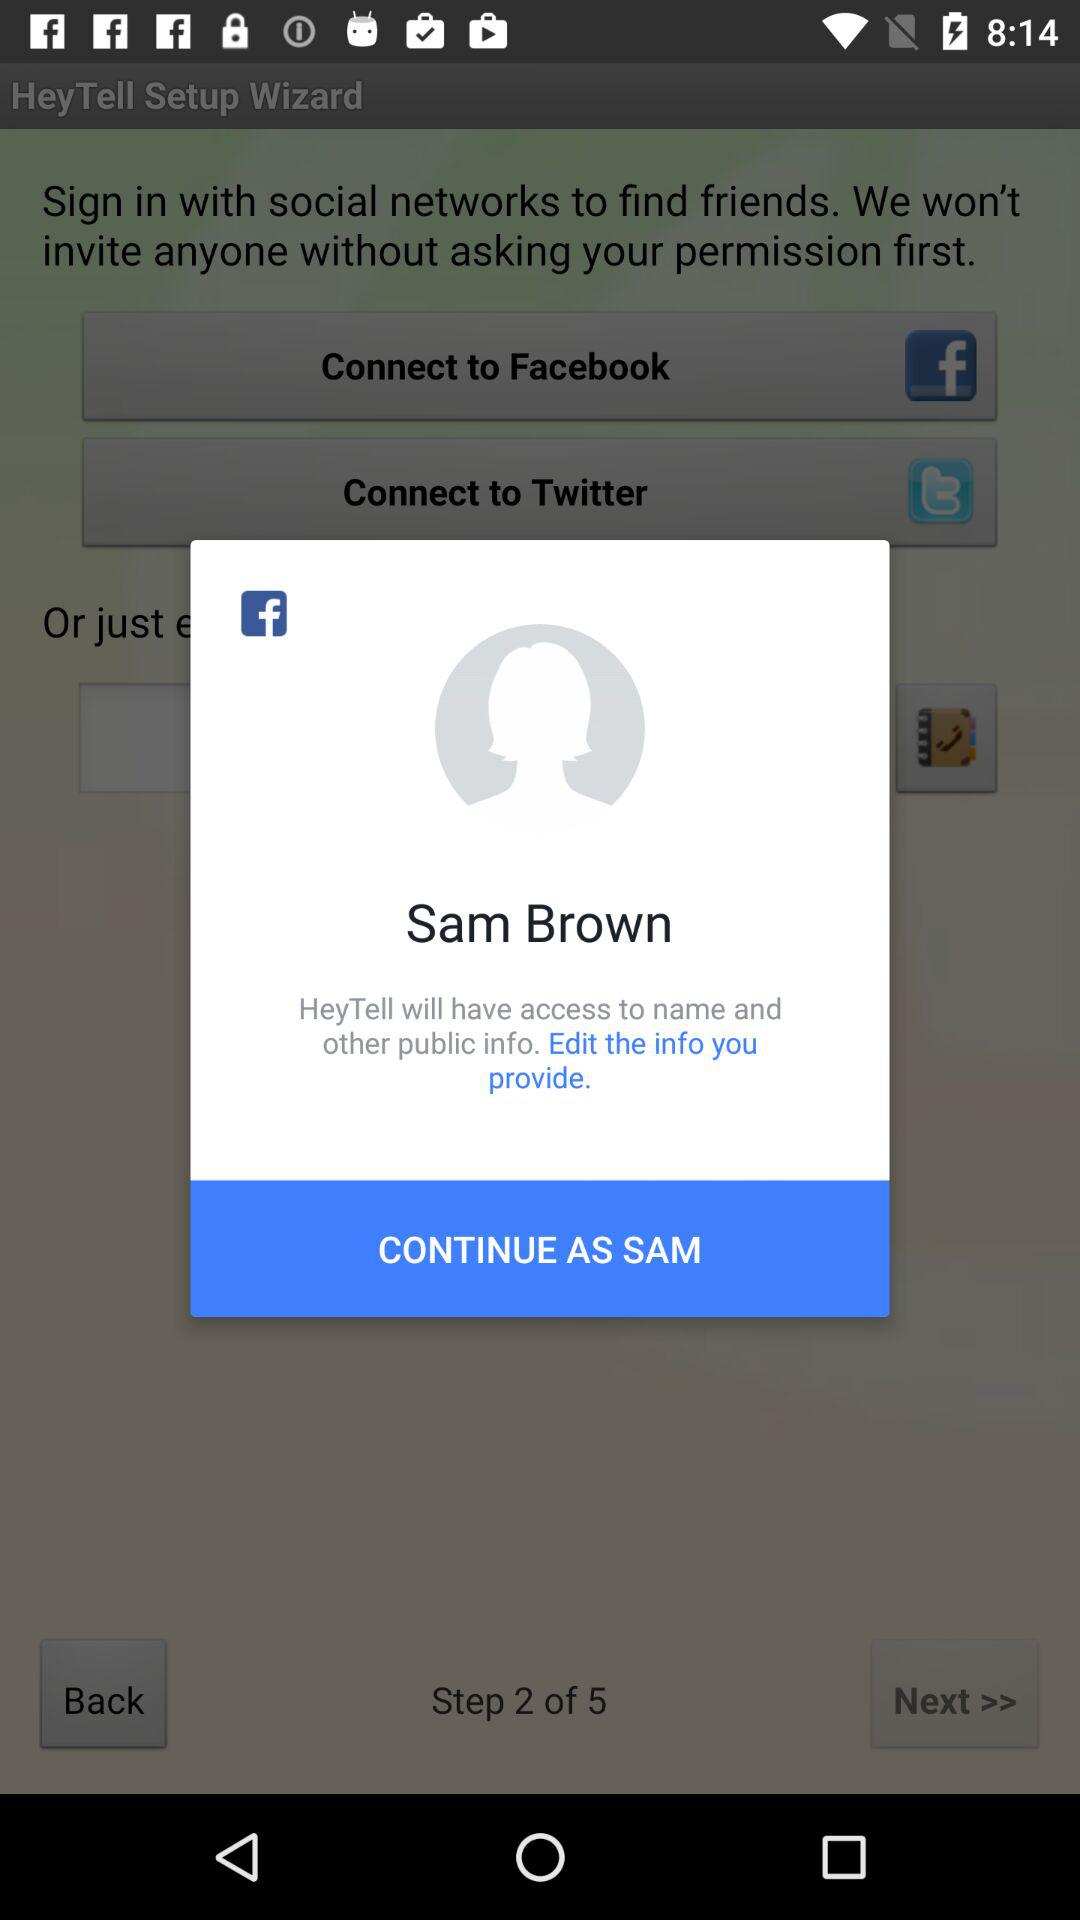What is the total number of steps? The total number of steps is 5. 